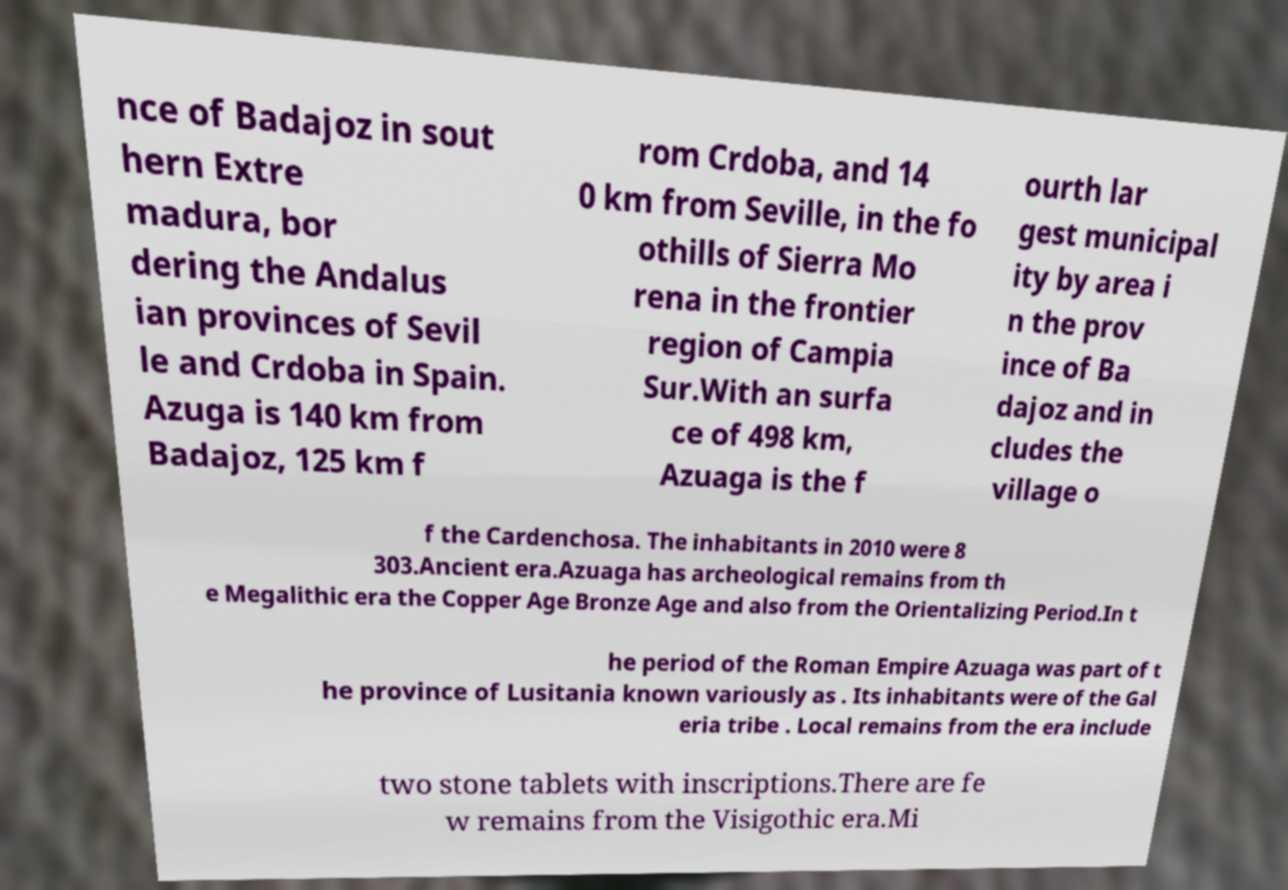Can you read and provide the text displayed in the image?This photo seems to have some interesting text. Can you extract and type it out for me? nce of Badajoz in sout hern Extre madura, bor dering the Andalus ian provinces of Sevil le and Crdoba in Spain. Azuga is 140 km from Badajoz, 125 km f rom Crdoba, and 14 0 km from Seville, in the fo othills of Sierra Mo rena in the frontier region of Campia Sur.With an surfa ce of 498 km, Azuaga is the f ourth lar gest municipal ity by area i n the prov ince of Ba dajoz and in cludes the village o f the Cardenchosa. The inhabitants in 2010 were 8 303.Ancient era.Azuaga has archeological remains from th e Megalithic era the Copper Age Bronze Age and also from the Orientalizing Period.In t he period of the Roman Empire Azuaga was part of t he province of Lusitania known variously as . Its inhabitants were of the Gal eria tribe . Local remains from the era include two stone tablets with inscriptions.There are fe w remains from the Visigothic era.Mi 